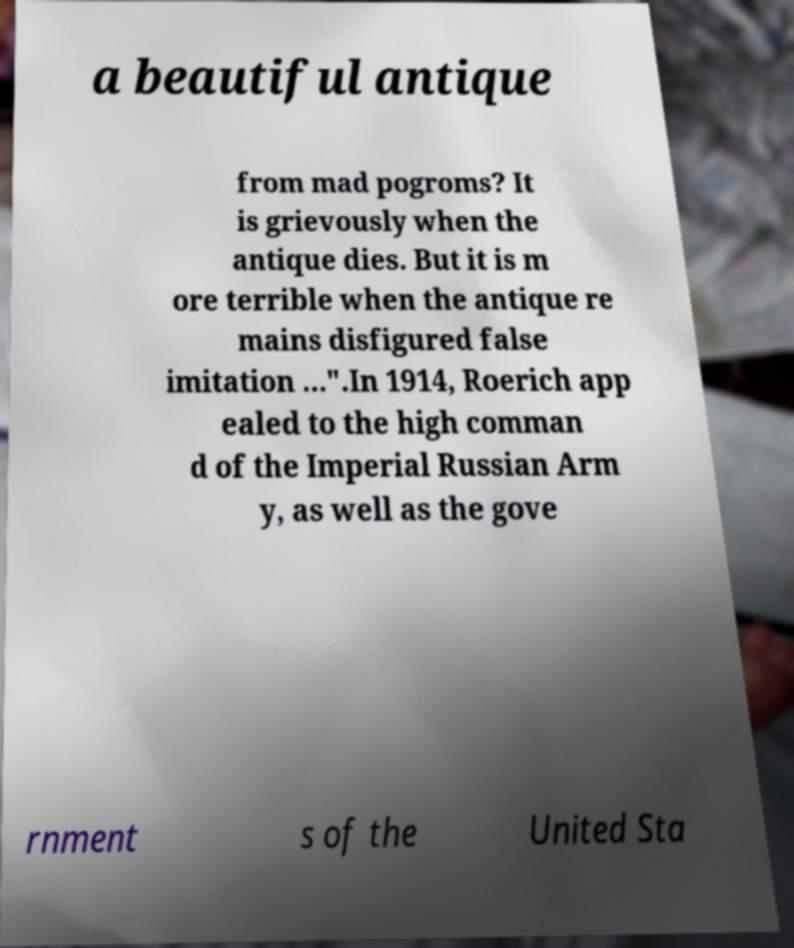What messages or text are displayed in this image? I need them in a readable, typed format. a beautiful antique from mad pogroms? It is grievously when the antique dies. But it is m ore terrible when the antique re mains disfigured false imitation ...".In 1914, Roerich app ealed to the high comman d of the Imperial Russian Arm y, as well as the gove rnment s of the United Sta 